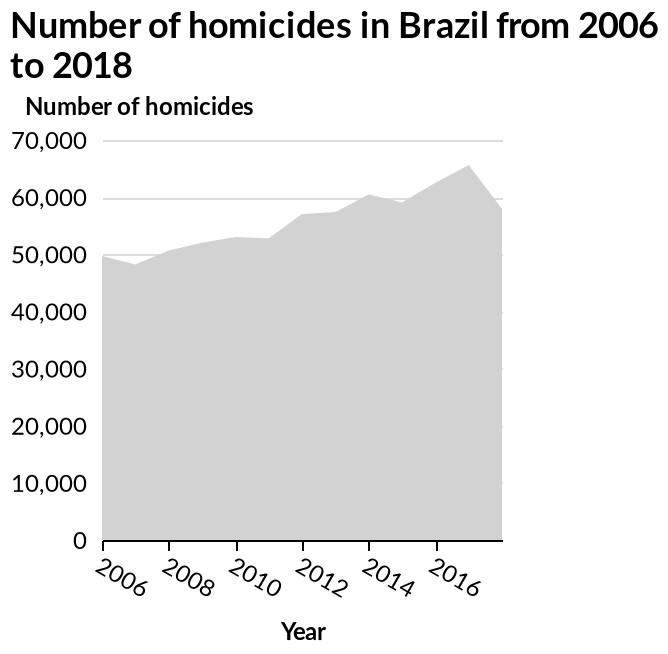<image>
Offer a thorough analysis of the image. The number of homicides in Brazil has been steadily rising from 50,000 in 2006 to 65,000 in 2016. In 2017 there was a big drop-off in homices from 65,000 down to around 58,000. What is the y-axis representing in the area plot? The y-axis represents the number of homicides in Brazil. please enumerates aspects of the construction of the chart Here a area plot is labeled Number of homicides in Brazil from 2006 to 2018. The y-axis plots Number of homicides with linear scale of range 0 to 70,000 while the x-axis measures Year on linear scale with a minimum of 2006 and a maximum of 2016. 